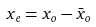<formula> <loc_0><loc_0><loc_500><loc_500>x _ { e } = x _ { o } - \bar { x } _ { o }</formula> 